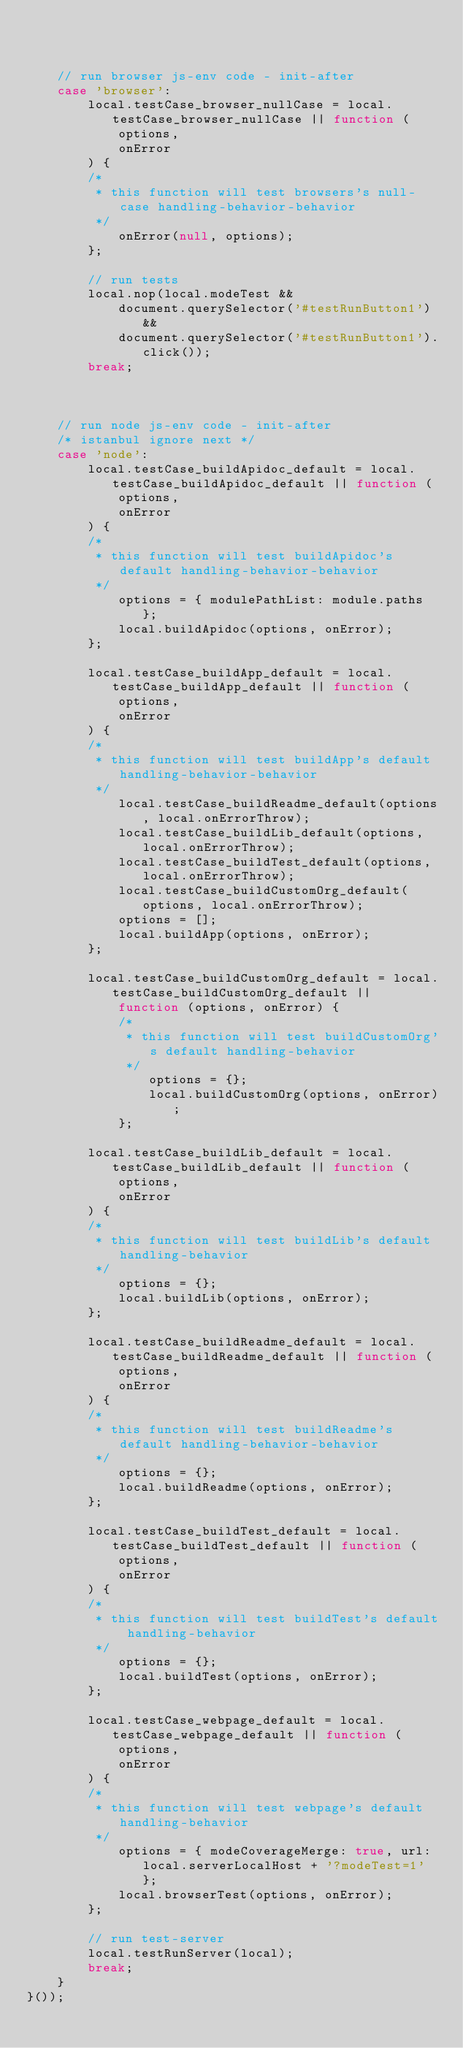Convert code to text. <code><loc_0><loc_0><loc_500><loc_500><_JavaScript_>


    // run browser js-env code - init-after
    case 'browser':
        local.testCase_browser_nullCase = local.testCase_browser_nullCase || function (
            options,
            onError
        ) {
        /*
         * this function will test browsers's null-case handling-behavior-behavior
         */
            onError(null, options);
        };

        // run tests
        local.nop(local.modeTest &&
            document.querySelector('#testRunButton1') &&
            document.querySelector('#testRunButton1').click());
        break;



    // run node js-env code - init-after
    /* istanbul ignore next */
    case 'node':
        local.testCase_buildApidoc_default = local.testCase_buildApidoc_default || function (
            options,
            onError
        ) {
        /*
         * this function will test buildApidoc's default handling-behavior-behavior
         */
            options = { modulePathList: module.paths };
            local.buildApidoc(options, onError);
        };

        local.testCase_buildApp_default = local.testCase_buildApp_default || function (
            options,
            onError
        ) {
        /*
         * this function will test buildApp's default handling-behavior-behavior
         */
            local.testCase_buildReadme_default(options, local.onErrorThrow);
            local.testCase_buildLib_default(options, local.onErrorThrow);
            local.testCase_buildTest_default(options, local.onErrorThrow);
            local.testCase_buildCustomOrg_default(options, local.onErrorThrow);
            options = [];
            local.buildApp(options, onError);
        };

        local.testCase_buildCustomOrg_default = local.testCase_buildCustomOrg_default ||
            function (options, onError) {
            /*
             * this function will test buildCustomOrg's default handling-behavior
             */
                options = {};
                local.buildCustomOrg(options, onError);
            };

        local.testCase_buildLib_default = local.testCase_buildLib_default || function (
            options,
            onError
        ) {
        /*
         * this function will test buildLib's default handling-behavior
         */
            options = {};
            local.buildLib(options, onError);
        };

        local.testCase_buildReadme_default = local.testCase_buildReadme_default || function (
            options,
            onError
        ) {
        /*
         * this function will test buildReadme's default handling-behavior-behavior
         */
            options = {};
            local.buildReadme(options, onError);
        };

        local.testCase_buildTest_default = local.testCase_buildTest_default || function (
            options,
            onError
        ) {
        /*
         * this function will test buildTest's default handling-behavior
         */
            options = {};
            local.buildTest(options, onError);
        };

        local.testCase_webpage_default = local.testCase_webpage_default || function (
            options,
            onError
        ) {
        /*
         * this function will test webpage's default handling-behavior
         */
            options = { modeCoverageMerge: true, url: local.serverLocalHost + '?modeTest=1' };
            local.browserTest(options, onError);
        };

        // run test-server
        local.testRunServer(local);
        break;
    }
}());
</code> 